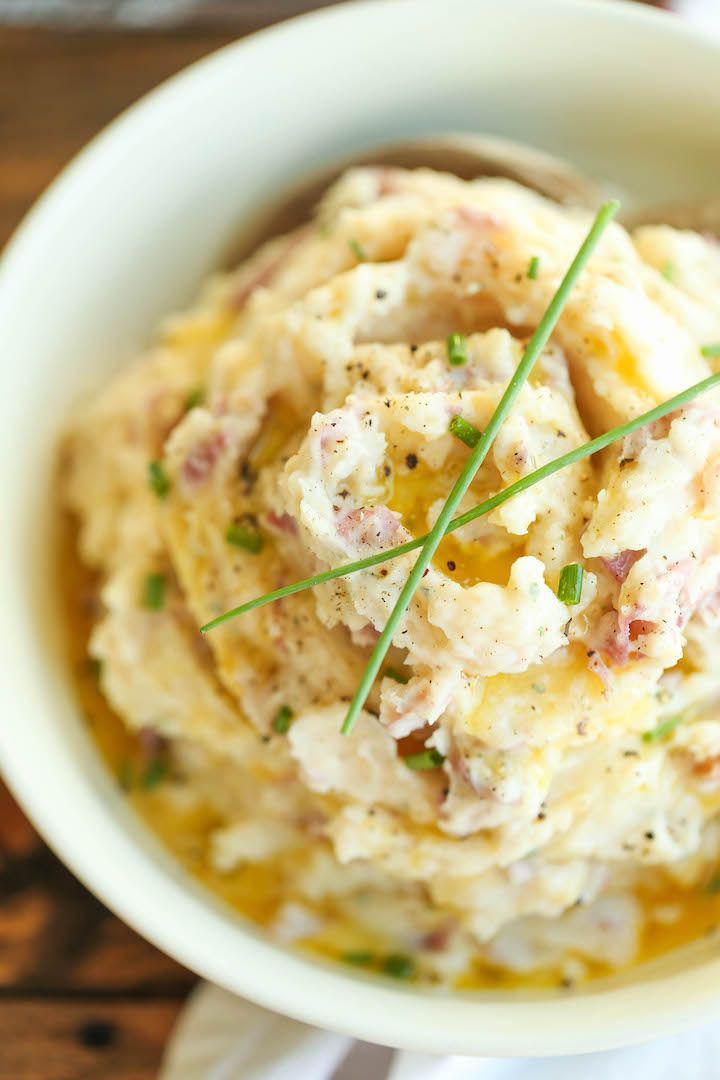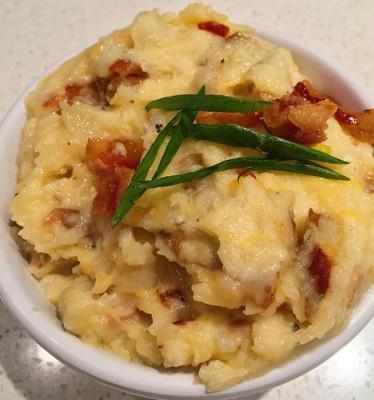The first image is the image on the left, the second image is the image on the right. Examine the images to the left and right. Is the description "There is one bowl of potatoes with a sprig of greenery on it in at least one of the images." accurate? Answer yes or no. Yes. 